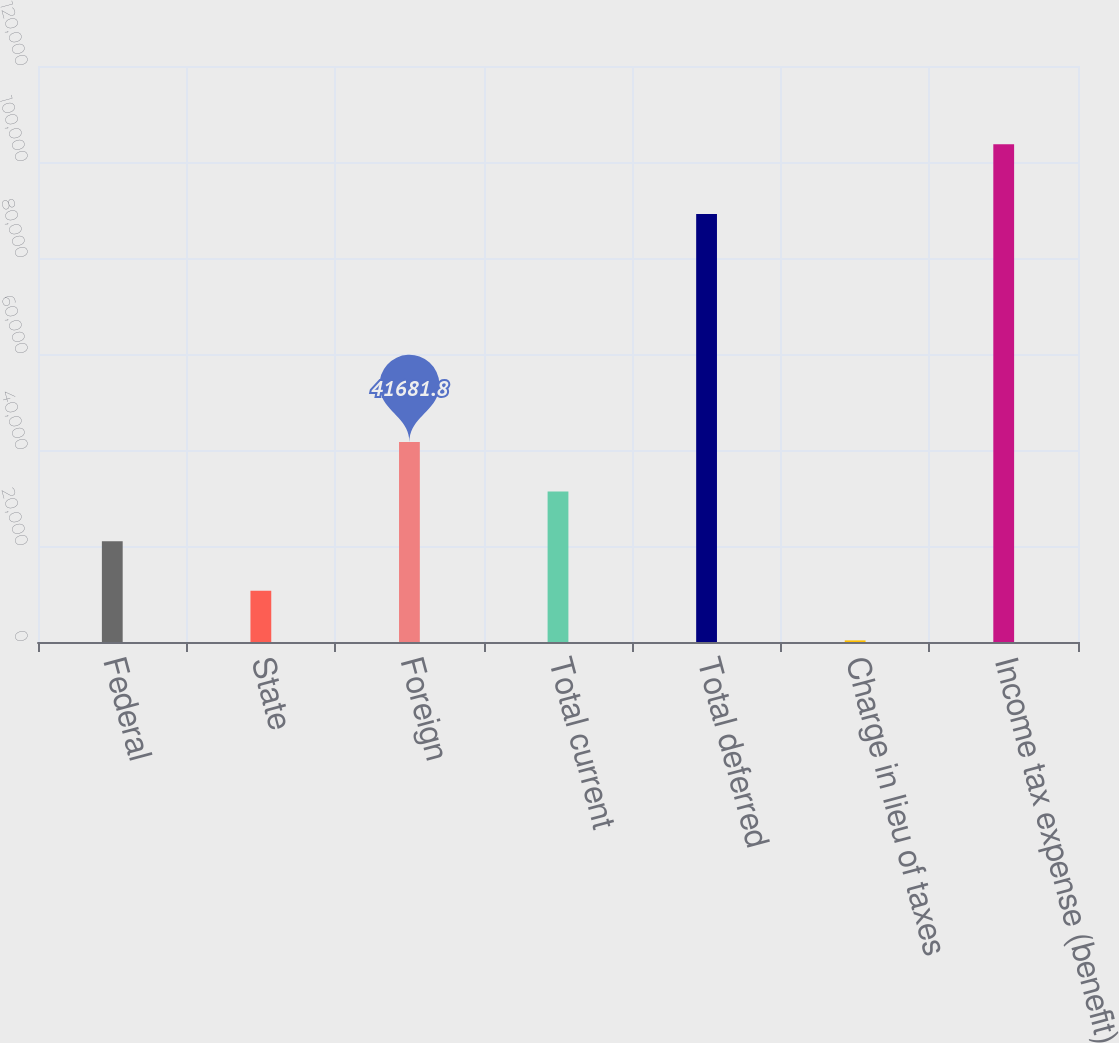Convert chart to OTSL. <chart><loc_0><loc_0><loc_500><loc_500><bar_chart><fcel>Federal<fcel>State<fcel>Foreign<fcel>Total current<fcel>Total deferred<fcel>Charge in lieu of taxes<fcel>Income tax expense (benefit)<nl><fcel>21010.4<fcel>10674.7<fcel>41681.8<fcel>31346.1<fcel>89164<fcel>339<fcel>103696<nl></chart> 